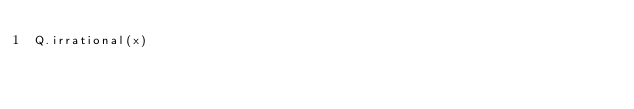Convert code to text. <code><loc_0><loc_0><loc_500><loc_500><_Python_>Q.irrational(x)</code> 